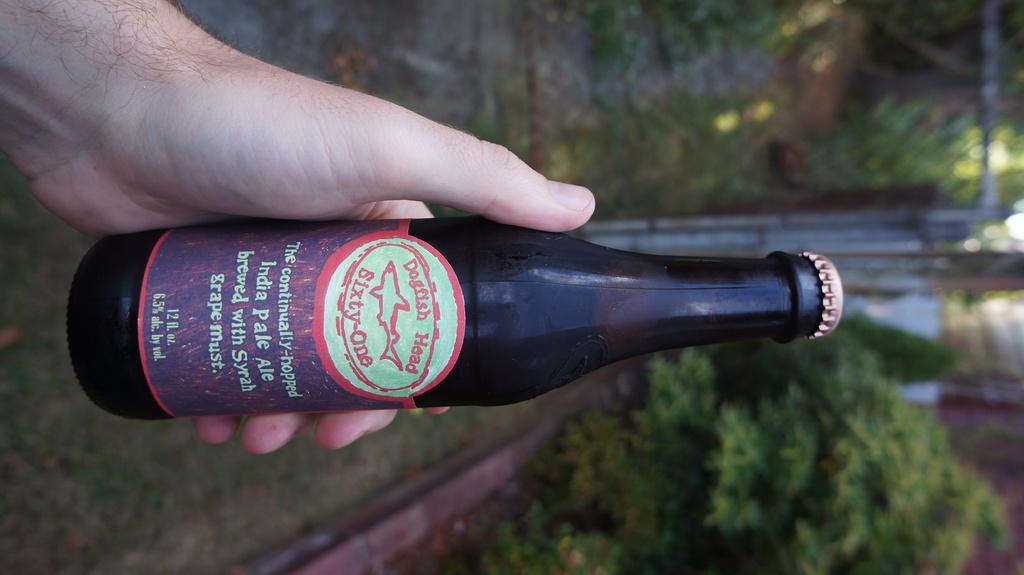What kind of beer is this?
Offer a very short reply. Dogfish head sixty-one. How many fluid ounces?
Provide a succinct answer. 12. 